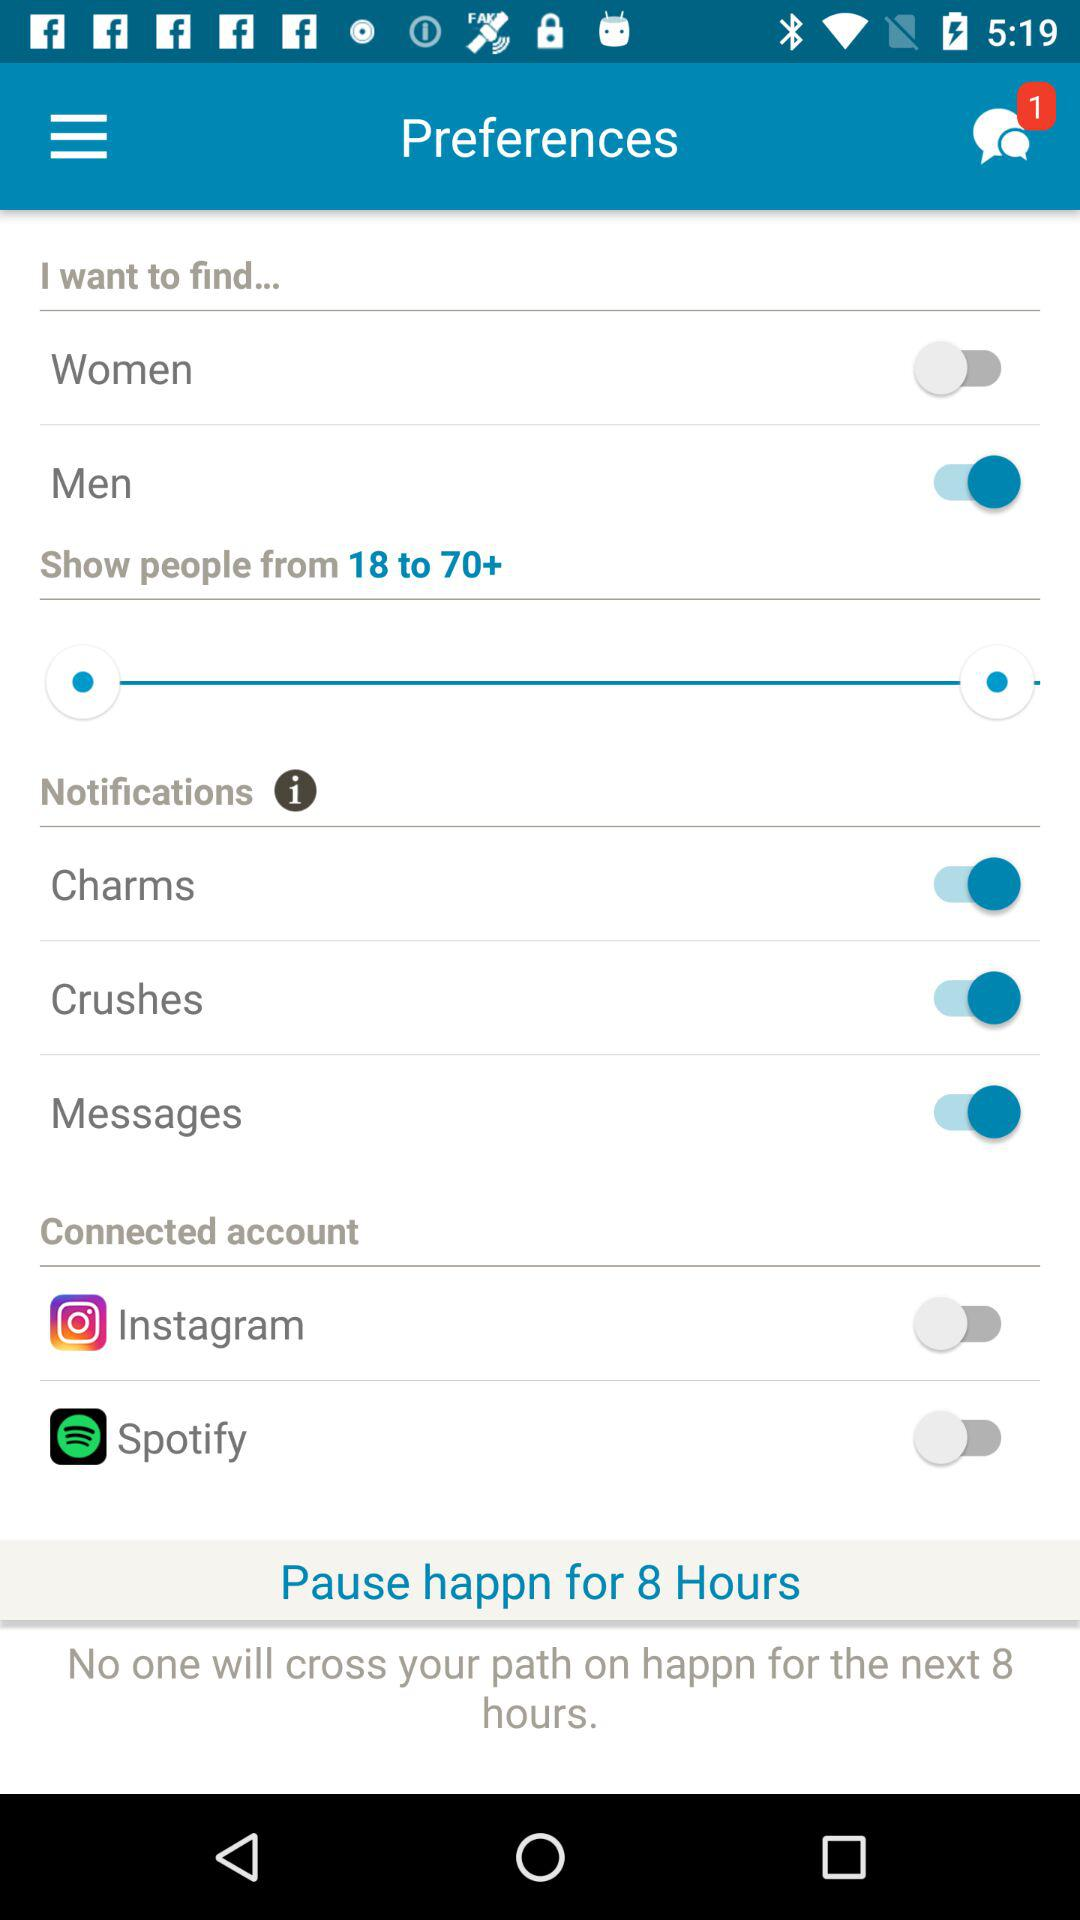What are the names of the connected accounts? The names are "Instagram" and "Spotify". 